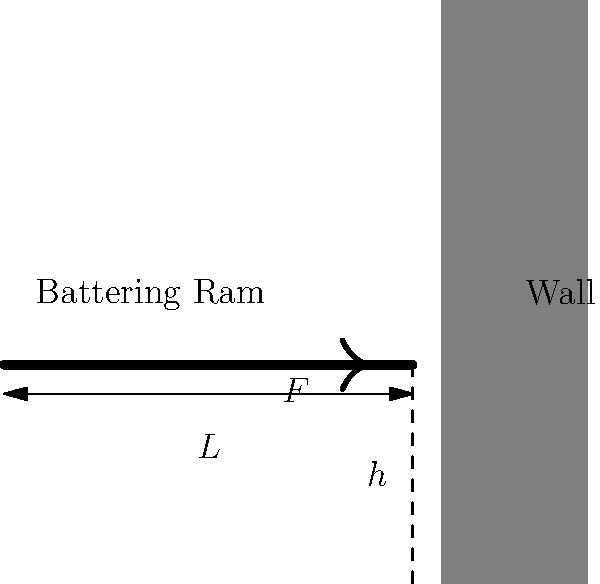A medieval Kazakh army is using a battering ram to breach a castle wall. The ram has a mass of 800 kg and is 3 m long. It strikes the wall at a height of 1.5 m from the ground with a velocity of 5 m/s. If the impact lasts for 0.1 seconds, what is the average pressure exerted on the wall if the contact area is 0.05 m²? Let's approach this step-by-step:

1) First, we need to calculate the force exerted by the battering ram. We can use the impulse-momentum theorem:

   $F \cdot \Delta t = m \cdot \Delta v$

   Where $F$ is the average force, $\Delta t$ is the impact time, $m$ is the mass, and $\Delta v$ is the change in velocity.

2) The ram comes to a stop, so $\Delta v = 5 - 0 = 5$ m/s

3) Plugging in the values:

   $F \cdot 0.1 = 800 \cdot 5$

4) Solving for $F$:

   $F = \frac{800 \cdot 5}{0.1} = 40,000$ N

5) Now that we have the force, we can calculate the pressure. Pressure is force per unit area:

   $P = \frac{F}{A}$

   Where $P$ is pressure, $F$ is force, and $A$ is area.

6) Plugging in our values:

   $P = \frac{40,000 \text{ N}}{0.05 \text{ m}^2} = 800,000 \text{ Pa} = 800 \text{ kPa}$

Therefore, the average pressure exerted on the wall is 800 kPa.
Answer: 800 kPa 